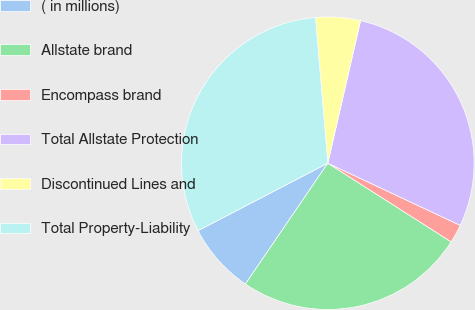Convert chart to OTSL. <chart><loc_0><loc_0><loc_500><loc_500><pie_chart><fcel>( in millions)<fcel>Allstate brand<fcel>Encompass brand<fcel>Total Allstate Protection<fcel>Discontinued Lines and<fcel>Total Property-Liability<nl><fcel>7.84%<fcel>25.49%<fcel>2.05%<fcel>28.39%<fcel>4.94%<fcel>31.29%<nl></chart> 